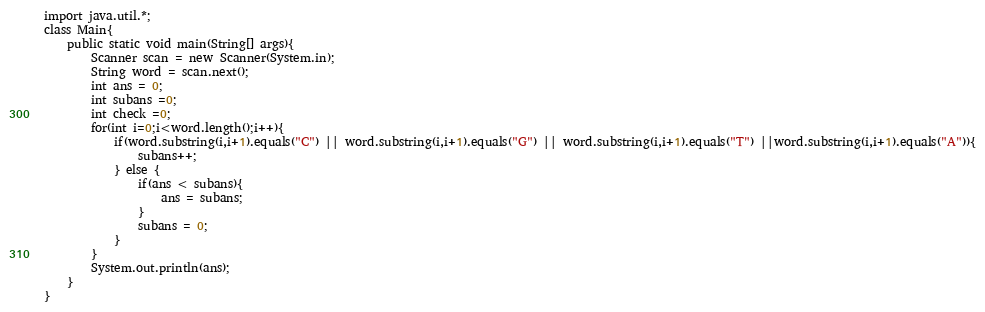<code> <loc_0><loc_0><loc_500><loc_500><_Java_>import java.util.*;
class Main{
	public static void main(String[] args){
    	Scanner scan = new Scanner(System.in);
      	String word = scan.next();
      	int ans = 0;
      	int subans =0;
      	int check =0;
      	for(int i=0;i<word.length();i++){
        	if(word.substring(i,i+1).equals("C") || word.substring(i,i+1).equals("G") || word.substring(i,i+1).equals("T") ||word.substring(i,i+1).equals("A")){
            	subans++;
            } else {
            	if(ans < subans){
                	ans = subans;
                }
              	subans = 0;
            }
        }
      	System.out.println(ans);
    }
}</code> 